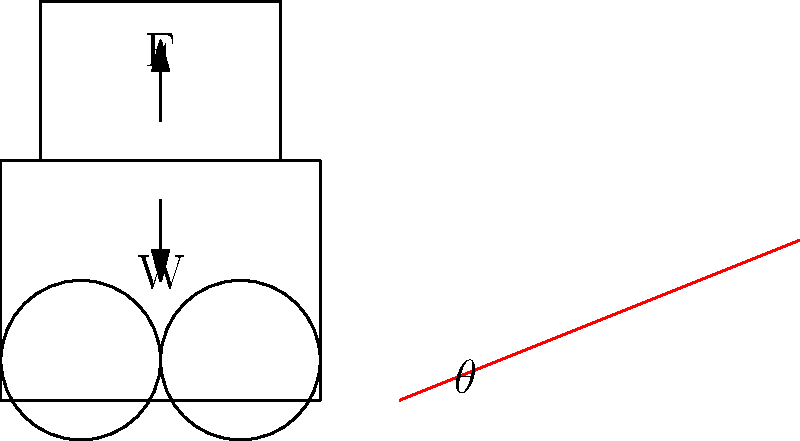A wheelchair user needs to ascend a ramp with an incline angle $\theta$. The combined weight of the user and wheelchair is $W = 120$ kg. What is the minimum force $F$ required to push the wheelchair up the ramp at a constant speed if the coefficient of rolling friction is $\mu = 0.02$ and the ramp angle is $\theta = 10°$? Assume $g = 9.8$ m/s². To solve this problem, we'll follow these steps:

1) First, let's identify the forces acting on the wheelchair-user system:
   - Weight (W) acting downward
   - Normal force (N) perpendicular to the ramp
   - Friction force (f) parallel to the ramp, opposing motion
   - Applied force (F) parallel to the ramp, in the direction of motion

2) The weight can be decomposed into two components:
   - Parallel to the ramp: $W \sin\theta$
   - Perpendicular to the ramp: $W \cos\theta$

3) The normal force N is equal to the perpendicular component of the weight:
   $N = W \cos\theta$

4) The friction force is given by:
   $f = \mu N = \mu W \cos\theta$

5) For constant speed motion, the sum of forces parallel to the ramp must be zero:
   $F - W \sin\theta - f = 0$

6) Substituting the expression for f:
   $F - W \sin\theta - \mu W \cos\theta = 0$

7) Solving for F:
   $F = W \sin\theta + \mu W \cos\theta$
   $F = W (\sin\theta + \mu \cos\theta)$

8) Now, let's plug in the values:
   $W = 120$ kg * $9.8$ m/s² = $1176$ N
   $\theta = 10°$
   $\mu = 0.02$

9) Calculate:
   $F = 1176 (\sin10° + 0.02 \cos10°)$
   $F = 1176 (0.1736 + 0.02 * 0.9848)$
   $F = 1176 (0.1736 + 0.0197)$
   $F = 1176 * 0.1933$
   $F = 227.32$ N

Therefore, the minimum force required is approximately 227.32 N.
Answer: 227.32 N 